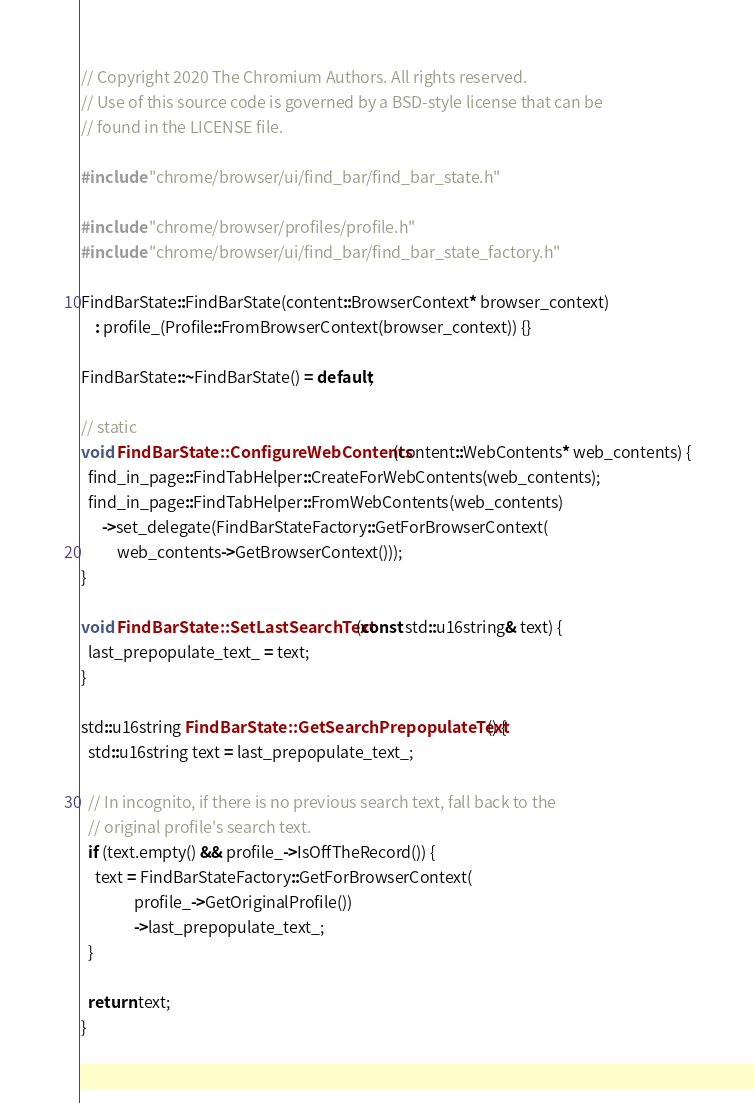Convert code to text. <code><loc_0><loc_0><loc_500><loc_500><_C++_>// Copyright 2020 The Chromium Authors. All rights reserved.
// Use of this source code is governed by a BSD-style license that can be
// found in the LICENSE file.

#include "chrome/browser/ui/find_bar/find_bar_state.h"

#include "chrome/browser/profiles/profile.h"
#include "chrome/browser/ui/find_bar/find_bar_state_factory.h"

FindBarState::FindBarState(content::BrowserContext* browser_context)
    : profile_(Profile::FromBrowserContext(browser_context)) {}

FindBarState::~FindBarState() = default;

// static
void FindBarState::ConfigureWebContents(content::WebContents* web_contents) {
  find_in_page::FindTabHelper::CreateForWebContents(web_contents);
  find_in_page::FindTabHelper::FromWebContents(web_contents)
      ->set_delegate(FindBarStateFactory::GetForBrowserContext(
          web_contents->GetBrowserContext()));
}

void FindBarState::SetLastSearchText(const std::u16string& text) {
  last_prepopulate_text_ = text;
}

std::u16string FindBarState::GetSearchPrepopulateText() {
  std::u16string text = last_prepopulate_text_;

  // In incognito, if there is no previous search text, fall back to the
  // original profile's search text.
  if (text.empty() && profile_->IsOffTheRecord()) {
    text = FindBarStateFactory::GetForBrowserContext(
               profile_->GetOriginalProfile())
               ->last_prepopulate_text_;
  }

  return text;
}
</code> 